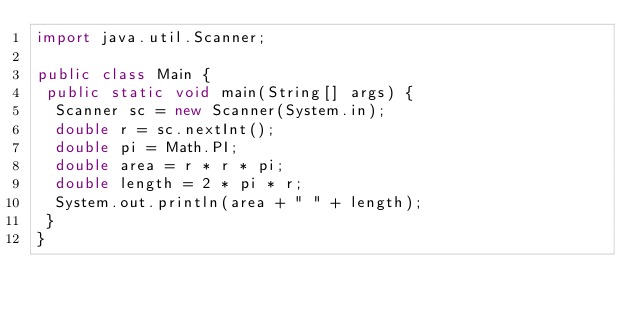<code> <loc_0><loc_0><loc_500><loc_500><_Java_>import java.util.Scanner;

public class Main {
 public static void main(String[] args) {
  Scanner sc = new Scanner(System.in);
  double r = sc.nextInt();
  double pi = Math.PI;
  double area = r * r * pi;
  double length = 2 * pi * r;
  System.out.println(area + " " + length);
 }
}</code> 